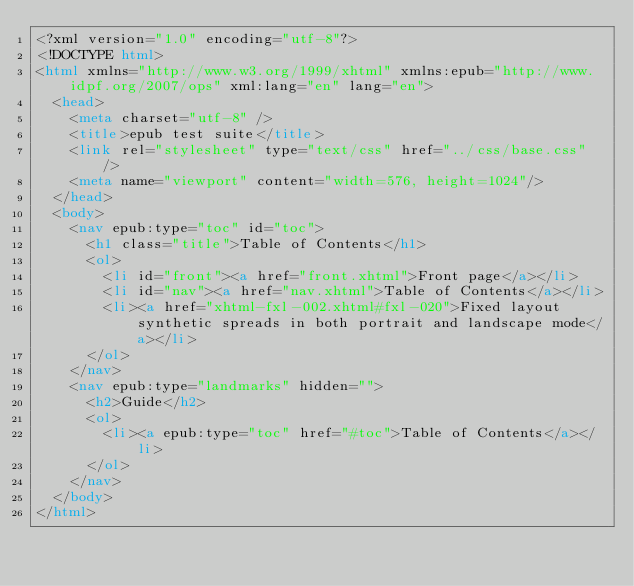<code> <loc_0><loc_0><loc_500><loc_500><_HTML_><?xml version="1.0" encoding="utf-8"?>
<!DOCTYPE html>
<html xmlns="http://www.w3.org/1999/xhtml" xmlns:epub="http://www.idpf.org/2007/ops" xml:lang="en" lang="en">
	<head>
		<meta charset="utf-8" />
		<title>epub test suite</title>
		<link rel="stylesheet" type="text/css" href="../css/base.css" />
		<meta name="viewport" content="width=576, height=1024"/>
	</head>
	<body>
		<nav epub:type="toc" id="toc">
			<h1 class="title">Table of Contents</h1>
			<ol>
				<li id="front"><a href="front.xhtml">Front page</a></li>
				<li id="nav"><a href="nav.xhtml">Table of Contents</a></li>
				<li><a href="xhtml-fxl-002.xhtml#fxl-020">Fixed layout synthetic spreads in both portrait and landscape mode</a></li>
			</ol>
		</nav>
		<nav epub:type="landmarks" hidden="">
			<h2>Guide</h2>
			<ol>
				<li><a epub:type="toc" href="#toc">Table of Contents</a></li>
			</ol>
		</nav>
	</body>
</html>
</code> 